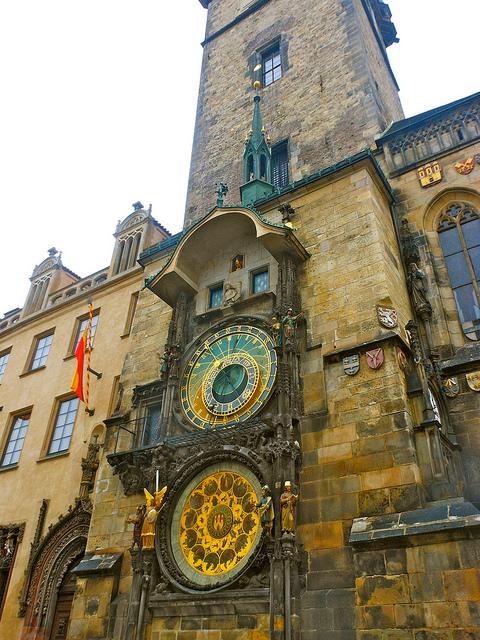Is the building tall?
Answer briefly. Yes. Does the building have any windows?
Give a very brief answer. Yes. Is that a modern building?
Write a very short answer. No. 